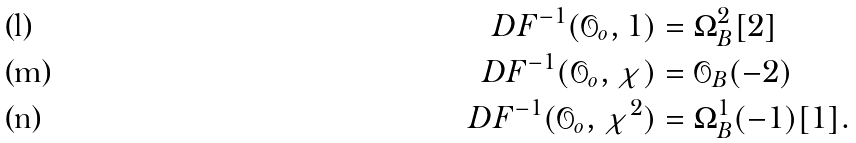Convert formula to latex. <formula><loc_0><loc_0><loc_500><loc_500>D F ^ { - 1 } ( { \mathcal { O } } _ { o } , 1 ) & = \Omega _ { B } ^ { 2 } [ 2 ] \\ D F ^ { - 1 } ( { \mathcal { O } } _ { o } , \chi ) & = { \mathcal { O } } _ { B } ( - 2 ) \\ D F ^ { - 1 } ( { \mathcal { O } } _ { o } , \chi ^ { 2 } ) & = \Omega _ { B } ^ { 1 } ( - 1 ) [ 1 ] .</formula> 